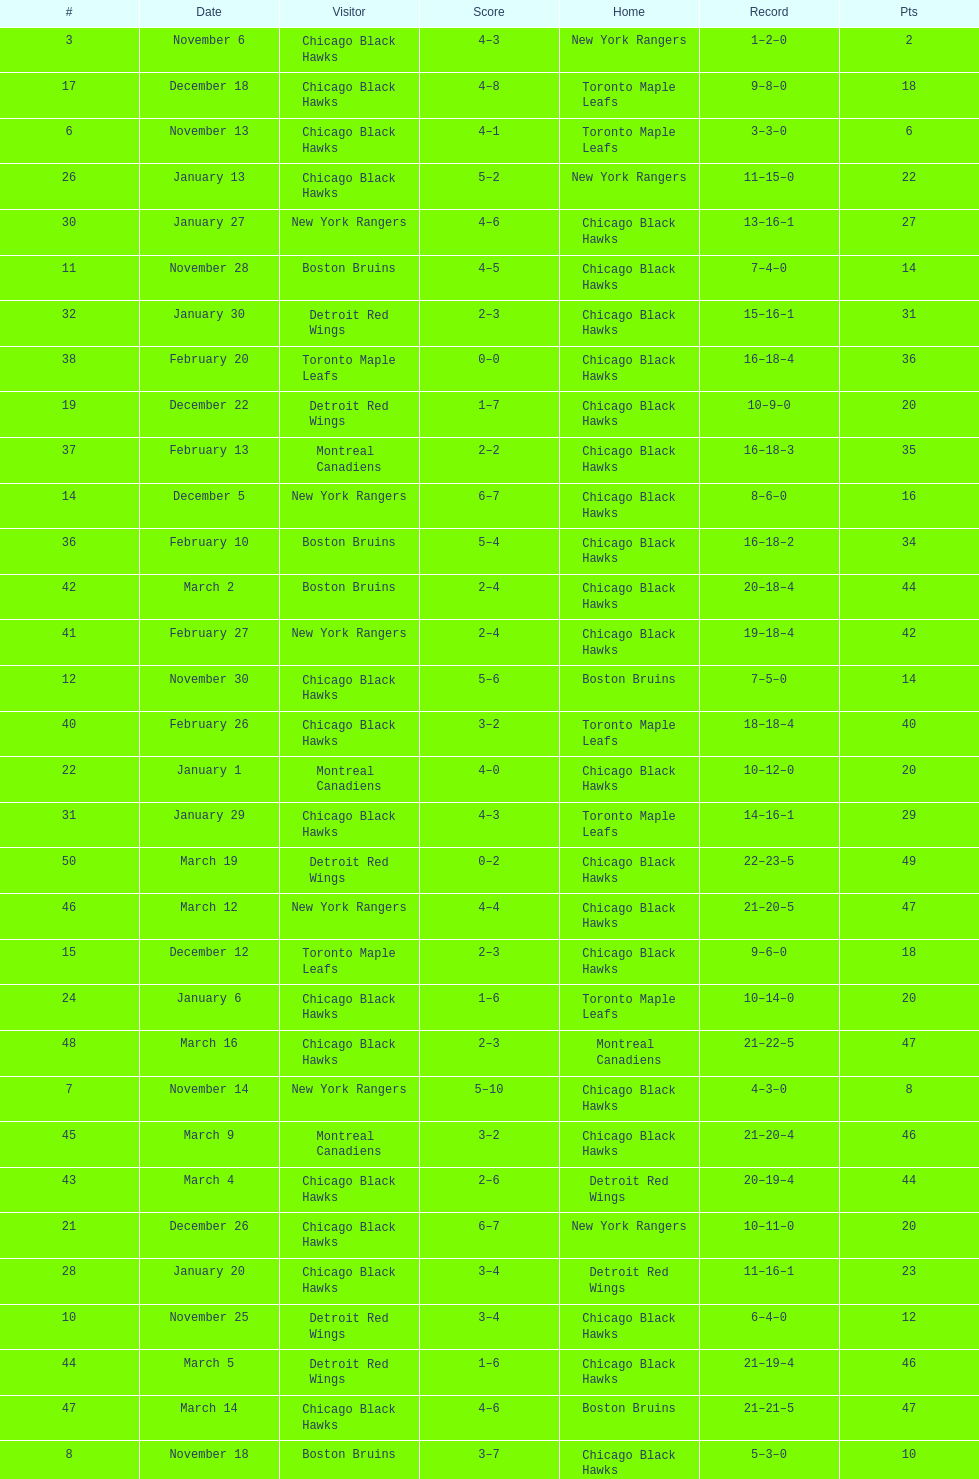On december 14 was the home team the chicago black hawks or the boston bruins? Boston Bruins. Can you parse all the data within this table? {'header': ['#', 'Date', 'Visitor', 'Score', 'Home', 'Record', 'Pts'], 'rows': [['3', 'November 6', 'Chicago Black Hawks', '4–3', 'New York Rangers', '1–2–0', '2'], ['17', 'December 18', 'Chicago Black Hawks', '4–8', 'Toronto Maple Leafs', '9–8–0', '18'], ['6', 'November 13', 'Chicago Black Hawks', '4–1', 'Toronto Maple Leafs', '3–3–0', '6'], ['26', 'January 13', 'Chicago Black Hawks', '5–2', 'New York Rangers', '11–15–0', '22'], ['30', 'January 27', 'New York Rangers', '4–6', 'Chicago Black Hawks', '13–16–1', '27'], ['11', 'November 28', 'Boston Bruins', '4–5', 'Chicago Black Hawks', '7–4–0', '14'], ['32', 'January 30', 'Detroit Red Wings', '2–3', 'Chicago Black Hawks', '15–16–1', '31'], ['38', 'February 20', 'Toronto Maple Leafs', '0–0', 'Chicago Black Hawks', '16–18–4', '36'], ['19', 'December 22', 'Detroit Red Wings', '1–7', 'Chicago Black Hawks', '10–9–0', '20'], ['37', 'February 13', 'Montreal Canadiens', '2–2', 'Chicago Black Hawks', '16–18–3', '35'], ['14', 'December 5', 'New York Rangers', '6–7', 'Chicago Black Hawks', '8–6–0', '16'], ['36', 'February 10', 'Boston Bruins', '5–4', 'Chicago Black Hawks', '16–18–2', '34'], ['42', 'March 2', 'Boston Bruins', '2–4', 'Chicago Black Hawks', '20–18–4', '44'], ['41', 'February 27', 'New York Rangers', '2–4', 'Chicago Black Hawks', '19–18–4', '42'], ['12', 'November 30', 'Chicago Black Hawks', '5–6', 'Boston Bruins', '7–5–0', '14'], ['40', 'February 26', 'Chicago Black Hawks', '3–2', 'Toronto Maple Leafs', '18–18–4', '40'], ['22', 'January 1', 'Montreal Canadiens', '4–0', 'Chicago Black Hawks', '10–12–0', '20'], ['31', 'January 29', 'Chicago Black Hawks', '4–3', 'Toronto Maple Leafs', '14–16–1', '29'], ['50', 'March 19', 'Detroit Red Wings', '0–2', 'Chicago Black Hawks', '22–23–5', '49'], ['46', 'March 12', 'New York Rangers', '4–4', 'Chicago Black Hawks', '21–20–5', '47'], ['15', 'December 12', 'Toronto Maple Leafs', '2–3', 'Chicago Black Hawks', '9–6–0', '18'], ['24', 'January 6', 'Chicago Black Hawks', '1–6', 'Toronto Maple Leafs', '10–14–0', '20'], ['48', 'March 16', 'Chicago Black Hawks', '2–3', 'Montreal Canadiens', '21–22–5', '47'], ['7', 'November 14', 'New York Rangers', '5–10', 'Chicago Black Hawks', '4–3–0', '8'], ['45', 'March 9', 'Montreal Canadiens', '3–2', 'Chicago Black Hawks', '21–20–4', '46'], ['43', 'March 4', 'Chicago Black Hawks', '2–6', 'Detroit Red Wings', '20–19–4', '44'], ['21', 'December 26', 'Chicago Black Hawks', '6–7', 'New York Rangers', '10–11–0', '20'], ['28', 'January 20', 'Chicago Black Hawks', '3–4', 'Detroit Red Wings', '11–16–1', '23'], ['10', 'November 25', 'Detroit Red Wings', '3–4', 'Chicago Black Hawks', '6–4–0', '12'], ['44', 'March 5', 'Detroit Red Wings', '1–6', 'Chicago Black Hawks', '21–19–4', '46'], ['47', 'March 14', 'Chicago Black Hawks', '4–6', 'Boston Bruins', '21–21–5', '47'], ['8', 'November 18', 'Boston Bruins', '3–7', 'Chicago Black Hawks', '5–3–0', '10'], ['2', 'November 4', 'Montreal Canadiens', '5–3', 'Chicago Black Hawks', '0–2–0', '0'], ['9', 'November 21', 'Chicago Black Hawks', '2–5', 'Detroit Red Wings', '5–4–0', '10'], ['1', 'October 31', 'Toronto Maple Leafs', '4–1', 'Chicago Black Hawks', '0–1–0', '0'], ['20', 'December 25', 'Chicago Black Hawks', '1–5', 'Montreal Canadiens', '10–10–0', '20'], ['49', 'March 18', 'Chicago Black Hawks', '3–6', 'Detroit Red Wings', '21–23–5', '47'], ['16', 'December 14', 'Chicago Black Hawks', '3–4', 'Boston Bruins', '9–7–0', '18'], ['35', 'February 6', 'Chicago Black Hawks', '4–4', 'New York Rangers', '16–17–2', '34'], ['5', 'November 11', 'Boston Bruins', '4–6', 'Chicago Black Hawks', '2–3–0', '4'], ['4', 'November 7', 'Chicago Black Hawks', '1–5', 'Montreal Canadiens', '1–3–0', '2'], ['23', 'January 4', 'Chicago Black Hawks', '4–6', 'Boston Bruins', '10–13–0', '20'], ['25', 'January 9', 'Chicago Black Hawks', '2–4', 'Detroit Red Wings', '10–15–0', '20'], ['33', 'February 1', 'Chicago Black Hawks', '2–0', 'Boston Bruins', '16–16–1', '33'], ['18', 'December 19', 'Toronto Maple Leafs', '5–2', 'Chicago Black Hawks', '9–9–0', '18'], ['13', 'December 2', 'Chicago Black Hawks', '2–6', 'Montreal Canadiens', '7–6–0', '14'], ['39', 'February 22', 'Chicago Black Hawks', '8–4', 'New York Rangers', '17–18–4', '38'], ['29', 'January 23', 'Toronto Maple Leafs', '3–5', 'Chicago Black Hawks', '12–16–1', '25'], ['27', 'January 16', 'Montreal Canadiens', '1–1', 'Chicago Black Hawks', '11–15–1', '23'], ['34', 'February 5', 'Chicago Black Hawks', '1–5', 'Montreal Canadiens', '16–17–1', '33']]} 